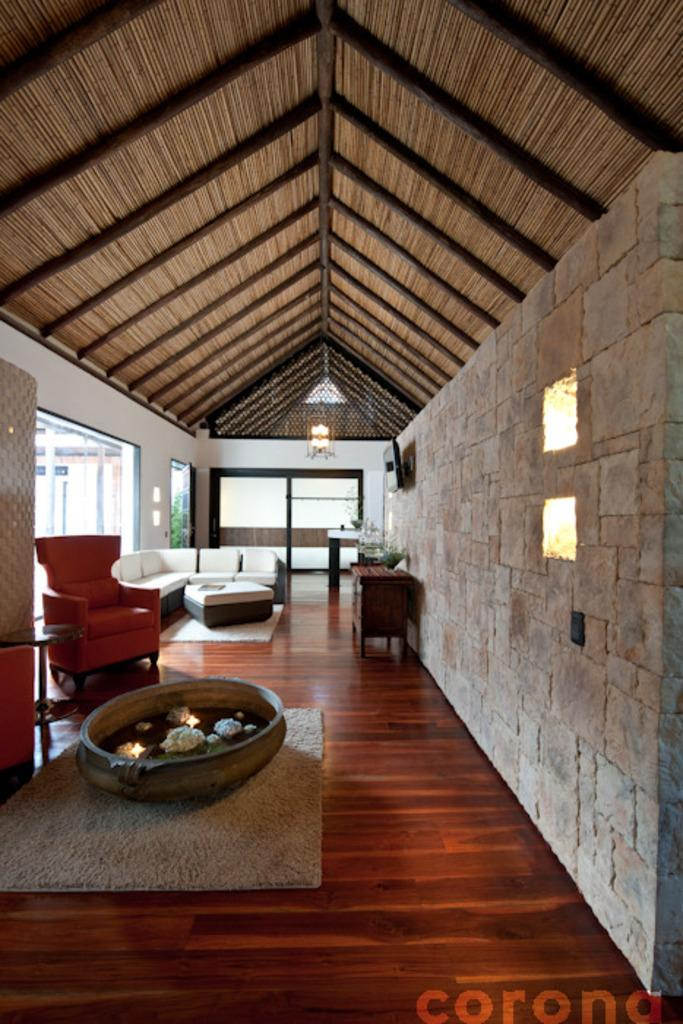What type of room is shown in the image? The image shows an inner view of a house. What furniture is present in the room? There is a sofa bed and a chair in the image. What type of turkey can be seen roasting on the chair in the image? There is no turkey present in the image, and the chair is not being used for roasting anything. 